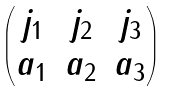Convert formula to latex. <formula><loc_0><loc_0><loc_500><loc_500>\begin{pmatrix} j _ { 1 } & j _ { 2 } & j _ { 3 } \\ a _ { 1 } & a _ { 2 } & a _ { 3 } \end{pmatrix}</formula> 